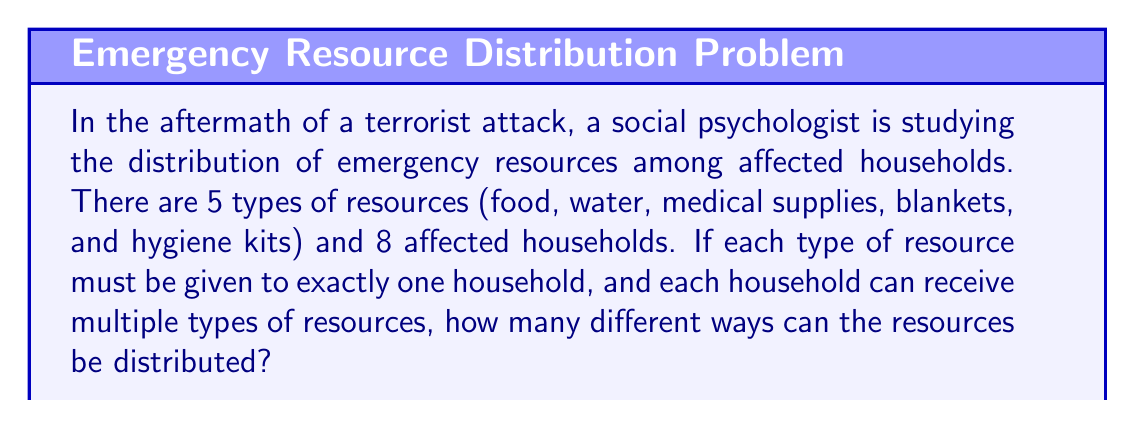Show me your answer to this math problem. Let's approach this step-by-step:

1) This problem is an application of the multiplication principle in combinatorics.

2) For each type of resource, we have 8 choices (households) to distribute it to.

3) We need to make this choice independently for each of the 5 types of resources.

4) According to the multiplication principle, if we have a series of independent choices, where there are $n_1$ ways of making the first choice, $n_2$ ways of making the second choice, and so on up to $n_k$ ways of making the $k$-th choice, then the total number of ways to make all these choices is:

   $$n_1 \times n_2 \times ... \times n_k$$

5) In our case, we have 5 choices (one for each resource type), and for each choice, we have 8 options (households).

6) Therefore, the total number of ways to distribute the resources is:

   $$8 \times 8 \times 8 \times 8 \times 8 = 8^5$$

7) We can calculate this:

   $$8^5 = 32,768$$

Thus, there are 32,768 different ways to distribute the resources among the affected households.
Answer: $32,768$ 